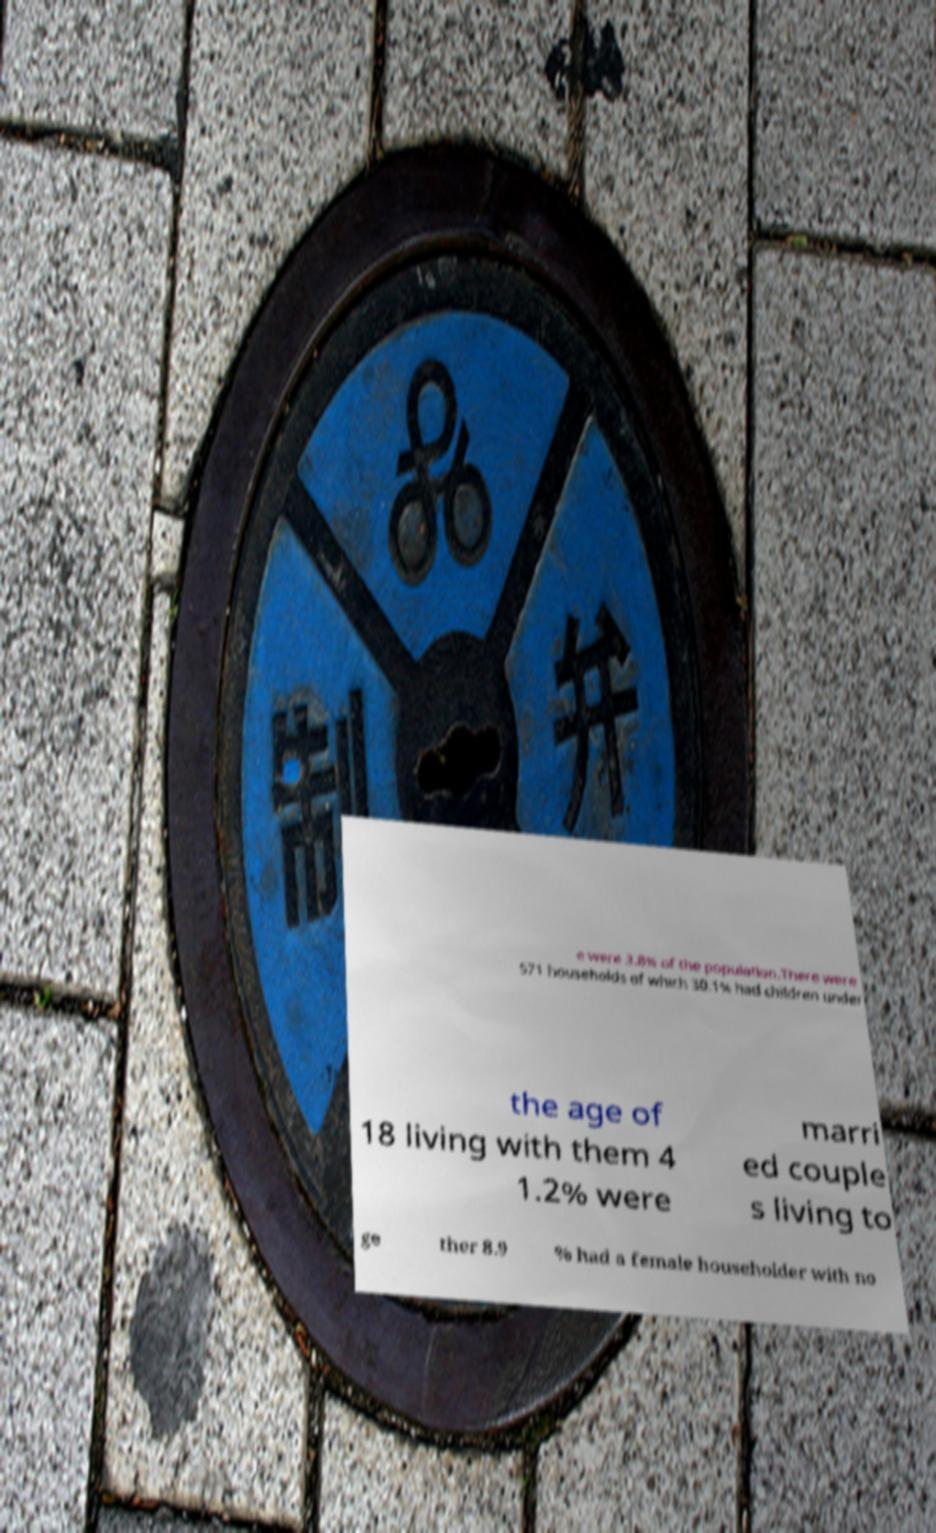Please identify and transcribe the text found in this image. e were 3.8% of the population.There were 571 households of which 30.1% had children under the age of 18 living with them 4 1.2% were marri ed couple s living to ge ther 8.9 % had a female householder with no 